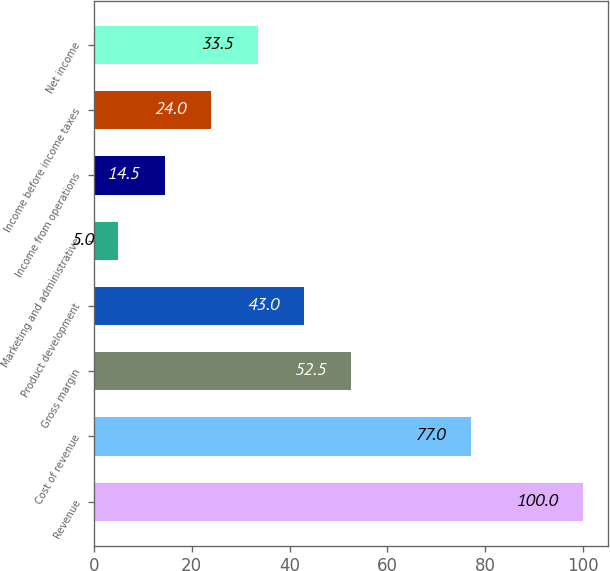<chart> <loc_0><loc_0><loc_500><loc_500><bar_chart><fcel>Revenue<fcel>Cost of revenue<fcel>Gross margin<fcel>Product development<fcel>Marketing and administrative<fcel>Income from operations<fcel>Income before income taxes<fcel>Net income<nl><fcel>100<fcel>77<fcel>52.5<fcel>43<fcel>5<fcel>14.5<fcel>24<fcel>33.5<nl></chart> 